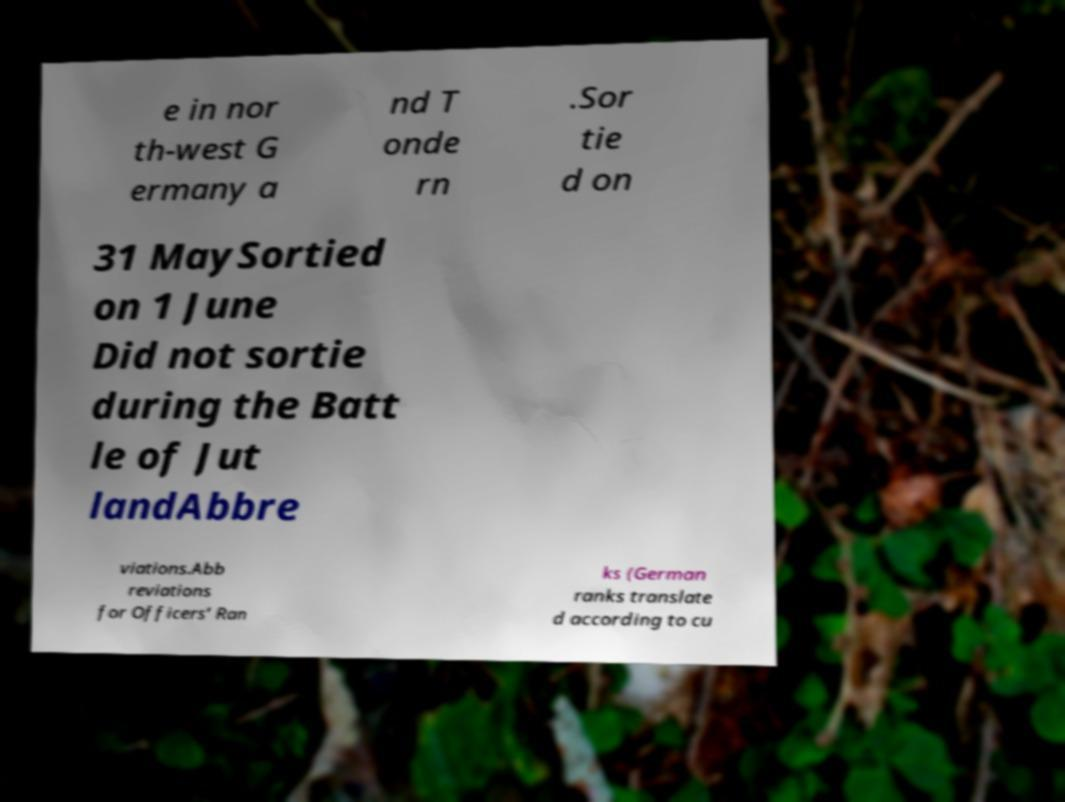Please read and relay the text visible in this image. What does it say? e in nor th-west G ermany a nd T onde rn .Sor tie d on 31 MaySortied on 1 June Did not sortie during the Batt le of Jut landAbbre viations.Abb reviations for Officers’ Ran ks (German ranks translate d according to cu 